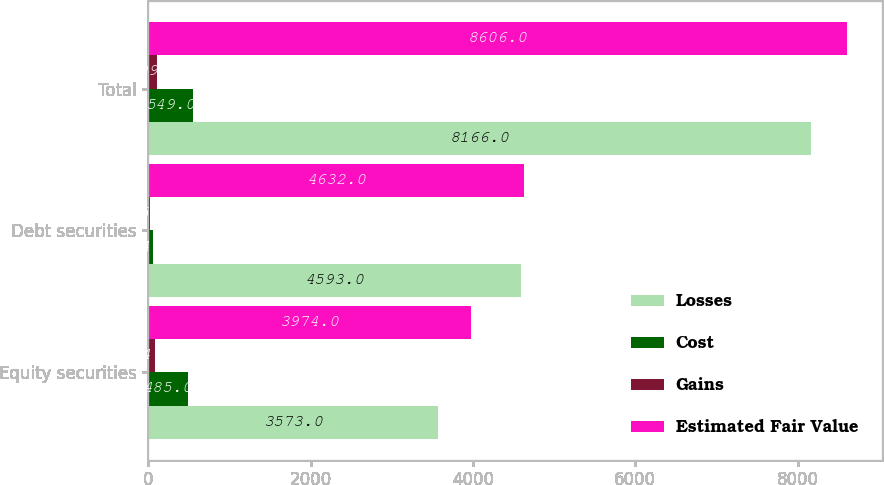<chart> <loc_0><loc_0><loc_500><loc_500><stacked_bar_chart><ecel><fcel>Equity securities<fcel>Debt securities<fcel>Total<nl><fcel>Losses<fcel>3573<fcel>4593<fcel>8166<nl><fcel>Cost<fcel>485<fcel>64<fcel>549<nl><fcel>Gains<fcel>84<fcel>25<fcel>109<nl><fcel>Estimated Fair Value<fcel>3974<fcel>4632<fcel>8606<nl></chart> 